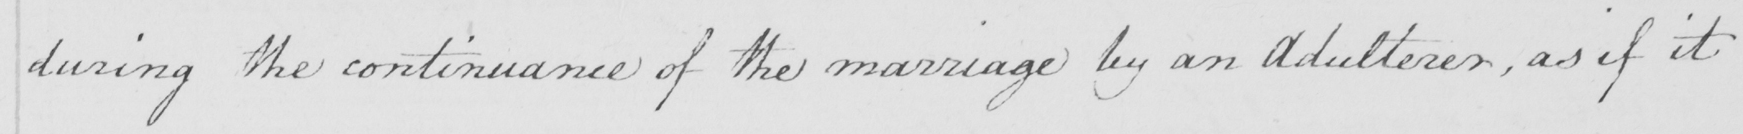Can you tell me what this handwritten text says? during the continuance of the marriage by and Adulterer , as if it 